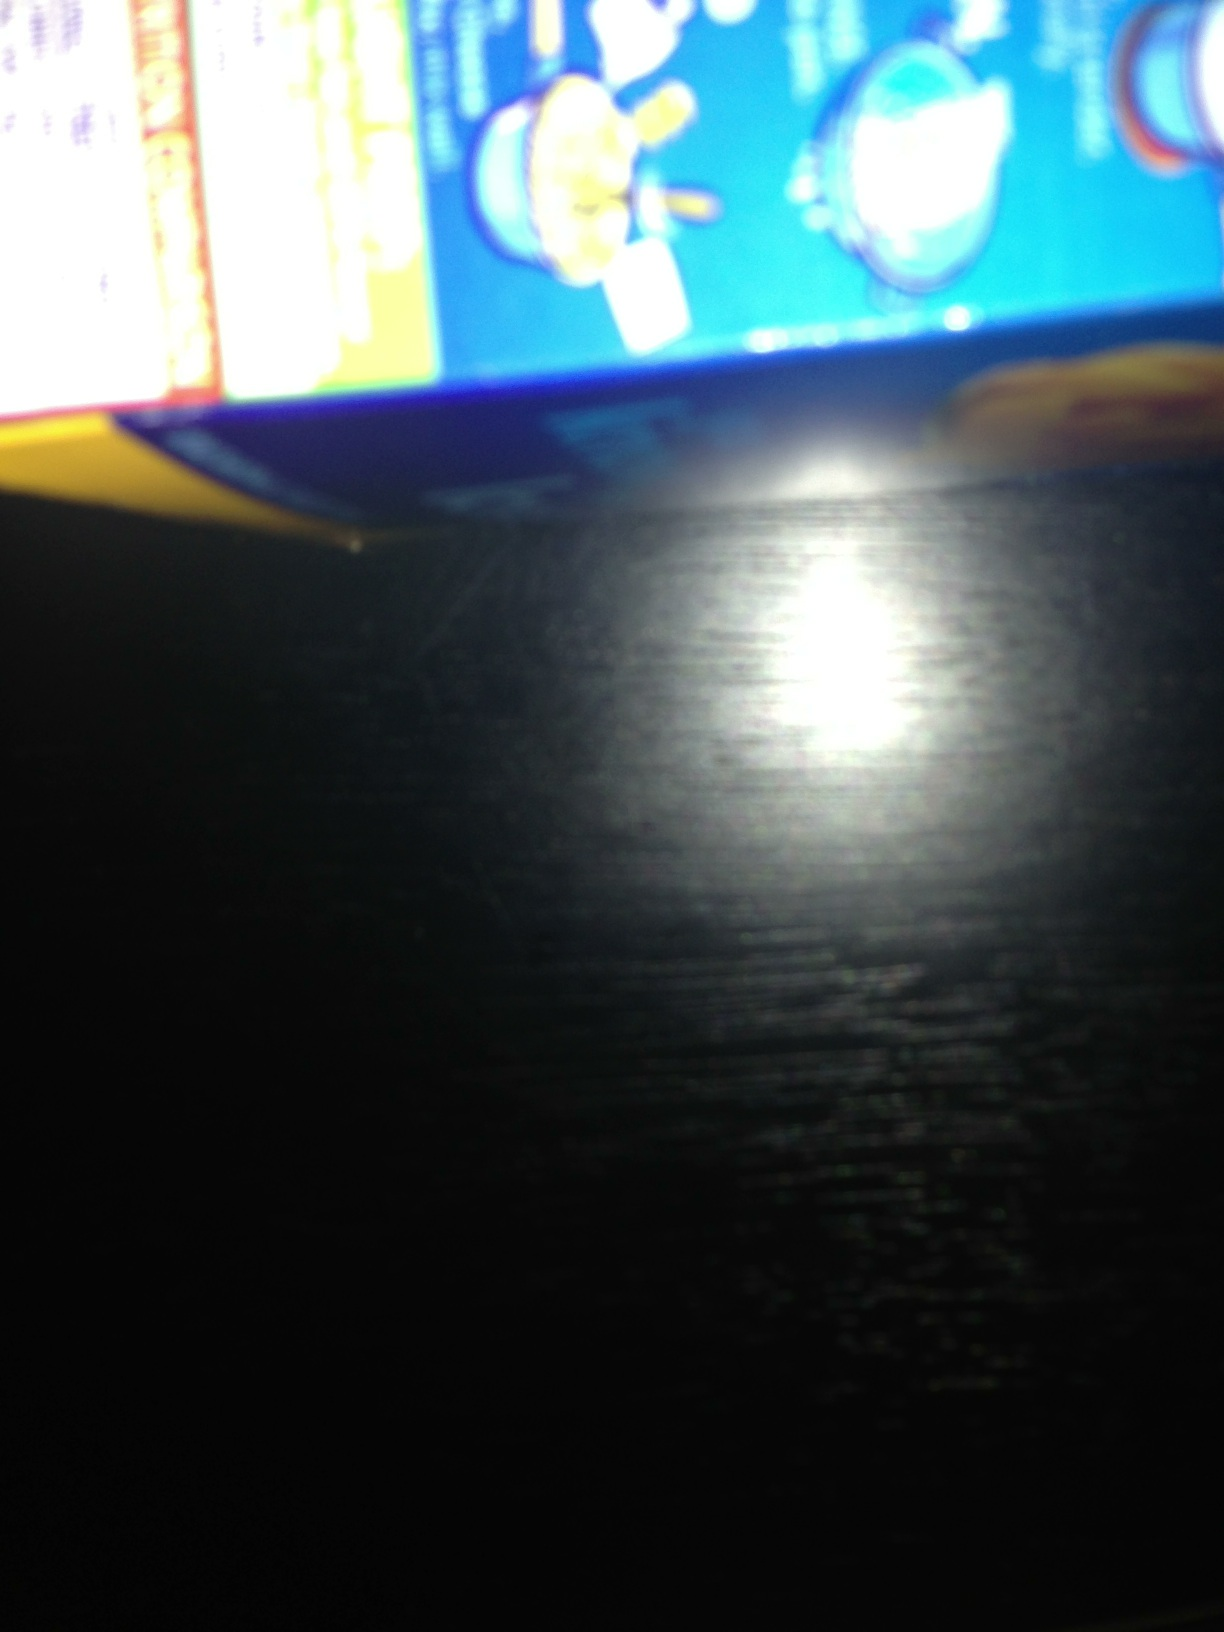I'd like to know what this box is about? The box appears to be related to food, likely a processed food product as it contains cooking instructions and pictorial representations of kitchenware like pots and pans. However, the image quality is insufficient to provide detailed information. Can you help me identify the brand or type of product? The brand and specific product type cannot be discerned clearly due to the blurry image. It would be helpful to take another photo from a clear and focused angle. Make sure the entire box is visible to capture important details. Why might it be important to follow the cooking instructions on a food product box? Following the cooking instructions on a food product box is important to ensure the food is prepared safely and correctly. These instructions are designed to achieve the best taste, texture, and to cook the food thoroughly, preventing any health risks associated with undercooked food. Imagine if this box contained a meal from the future, what sort of futuristic cooking instructions might it have? In the future, cooking instructions on meal boxes might include scanning a QR code that connects to a holographic chef guiding you step-by-step. The instructions could interact with smart kitchen devices that adjust the heat, stir the food, and even alert you when it's time to add the next ingredient. Ingredients might be nanotechnologically enhanced to cook in seconds or change flavor profiles with the push of a button, offering personalized adjustments based on dietary needs and preferences. 